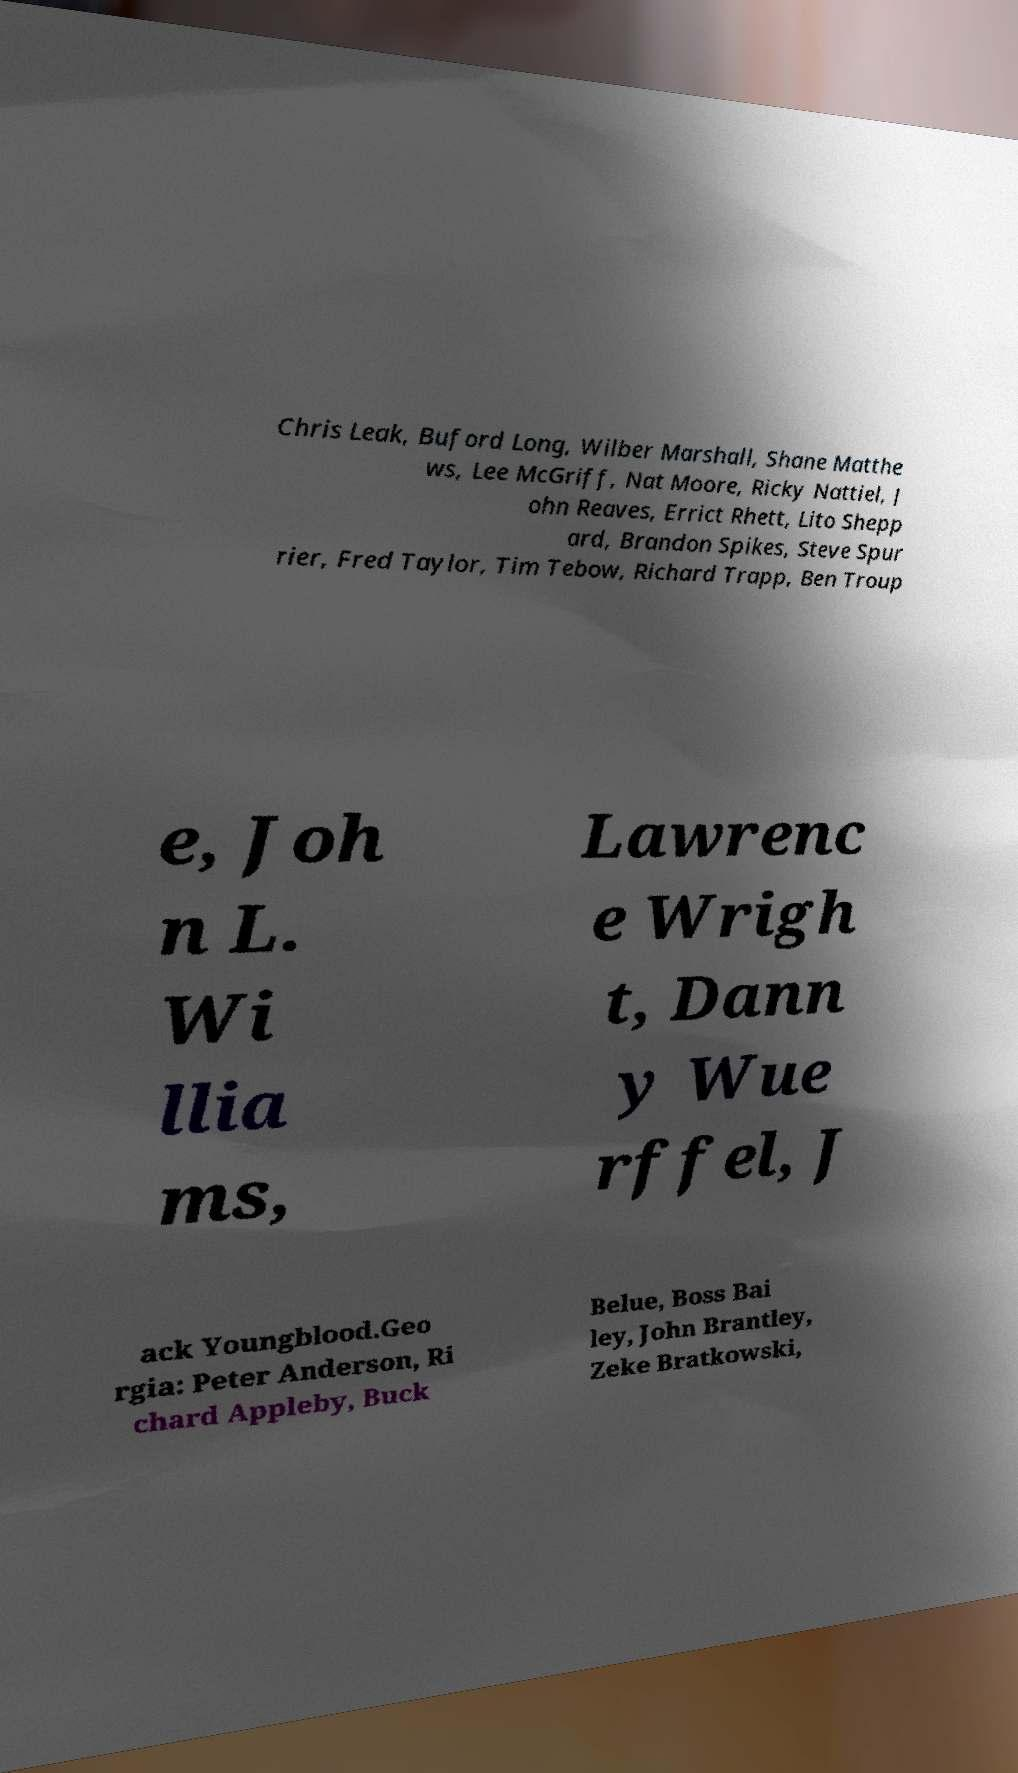Can you accurately transcribe the text from the provided image for me? Chris Leak, Buford Long, Wilber Marshall, Shane Matthe ws, Lee McGriff, Nat Moore, Ricky Nattiel, J ohn Reaves, Errict Rhett, Lito Shepp ard, Brandon Spikes, Steve Spur rier, Fred Taylor, Tim Tebow, Richard Trapp, Ben Troup e, Joh n L. Wi llia ms, Lawrenc e Wrigh t, Dann y Wue rffel, J ack Youngblood.Geo rgia: Peter Anderson, Ri chard Appleby, Buck Belue, Boss Bai ley, John Brantley, Zeke Bratkowski, 